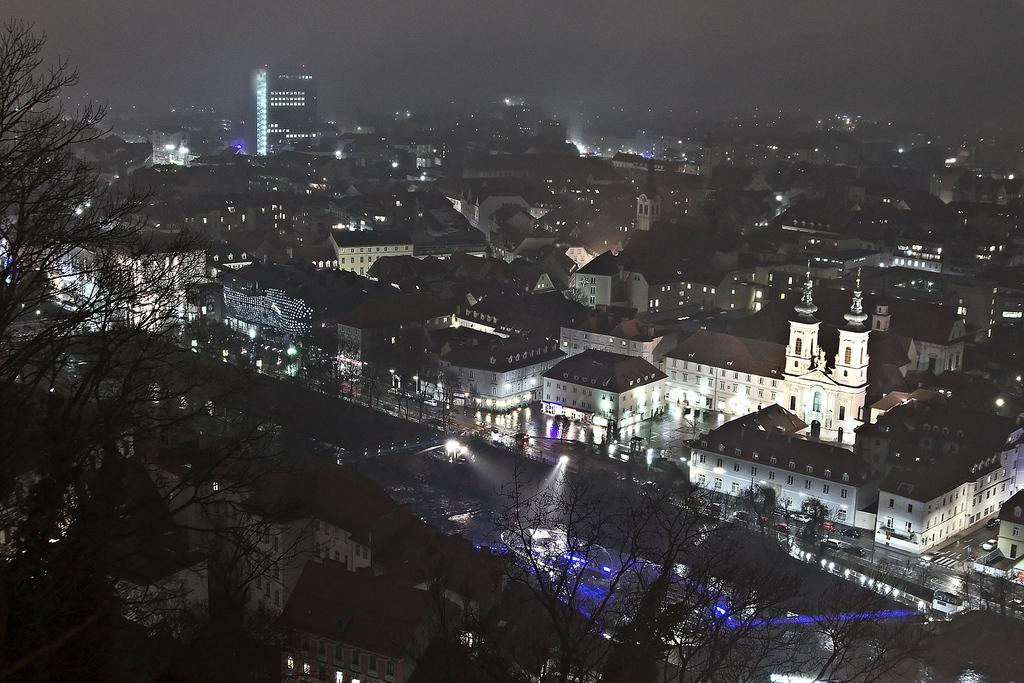What type of structures can be seen in the image? There are buildings in the image. What else is visible in the image besides the buildings? There are lights, water, trees, and the sky visible in the image. Can you describe the lighting conditions in the image? The image appears to be slightly dark. How many eyes can be seen on the cat in the image? There is no cat present in the image, so it is not possible to determine the number of eyes. What type of soap is being used to clean the water in the image? There is no soap or cleaning activity depicted in the image; it simply shows water, buildings, lights, trees, and the sky. 